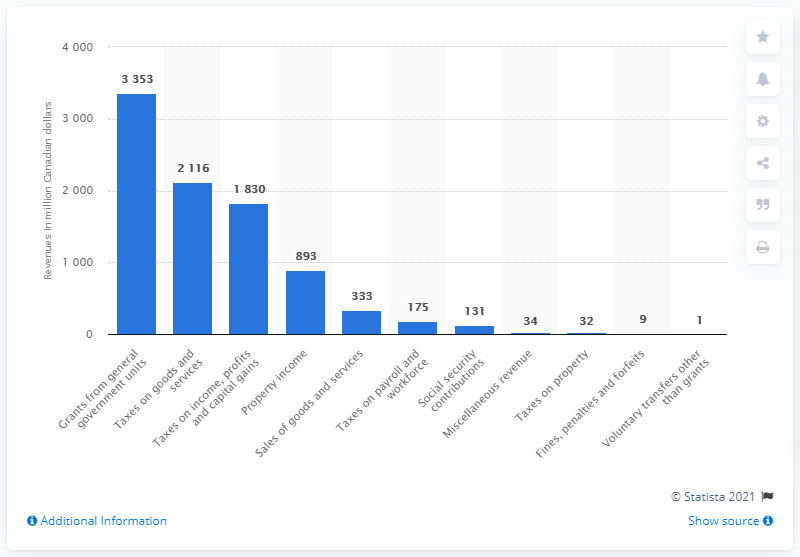List a handful of essential elements in this visual. In 2019, the Newfoundland and Labrador government collected approximately $211.6 million in revenue through taxes on goods and services. 